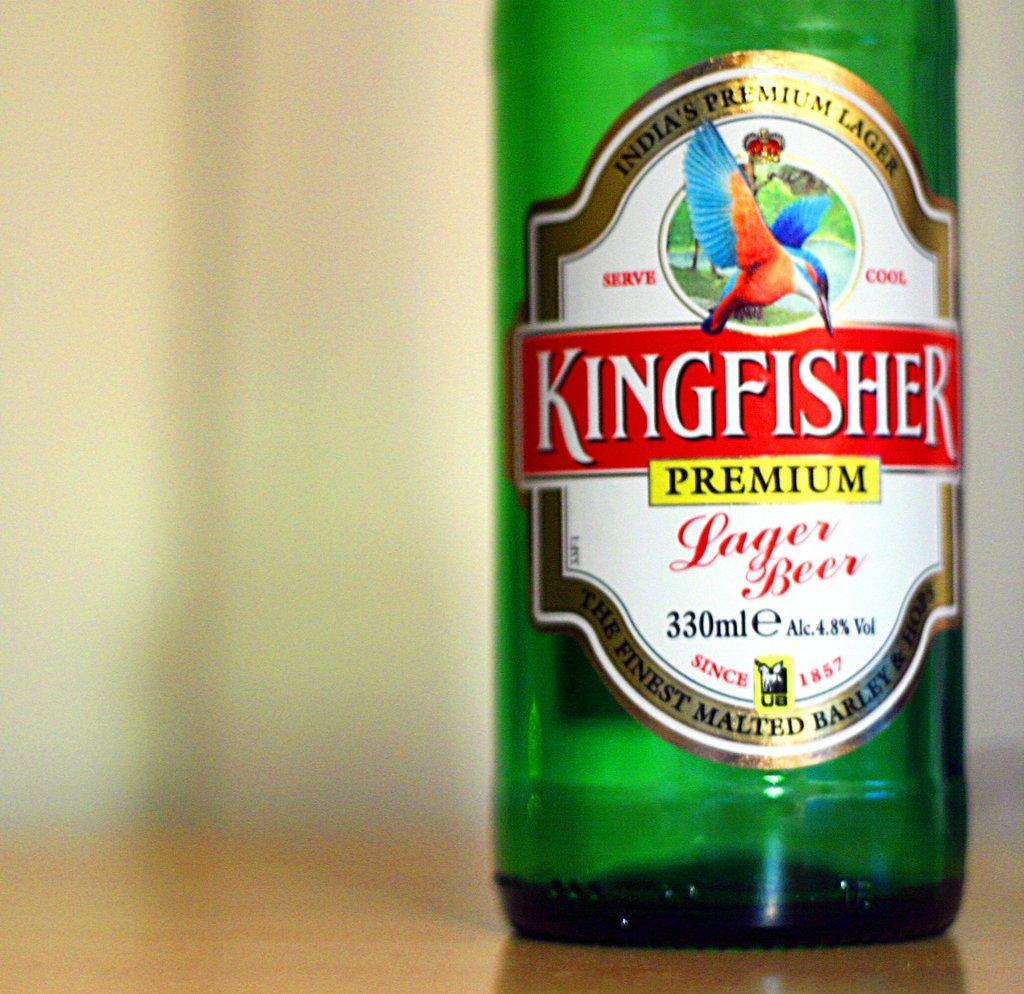Describe this image in one or two sentences. There is a green bottle and on the green bottle there is a label and it is on a surface. 